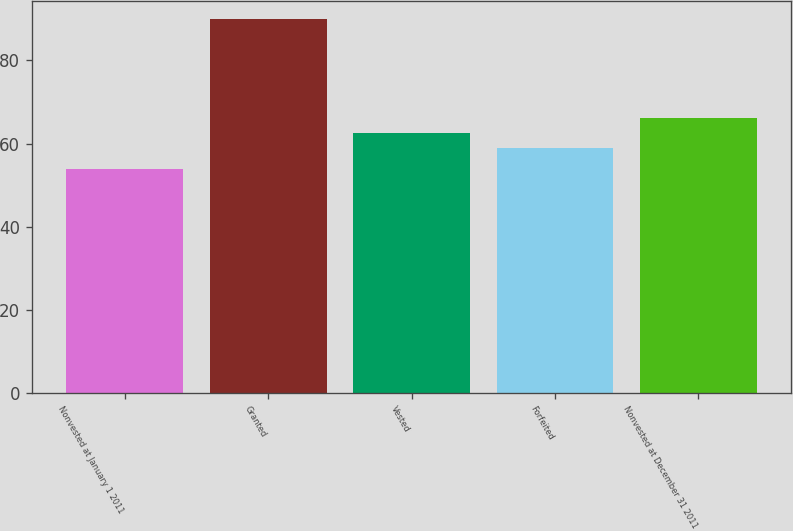<chart> <loc_0><loc_0><loc_500><loc_500><bar_chart><fcel>Nonvested at January 1 2011<fcel>Granted<fcel>Vested<fcel>Forfeited<fcel>Nonvested at December 31 2011<nl><fcel>53.93<fcel>89.87<fcel>62.48<fcel>58.89<fcel>66.07<nl></chart> 